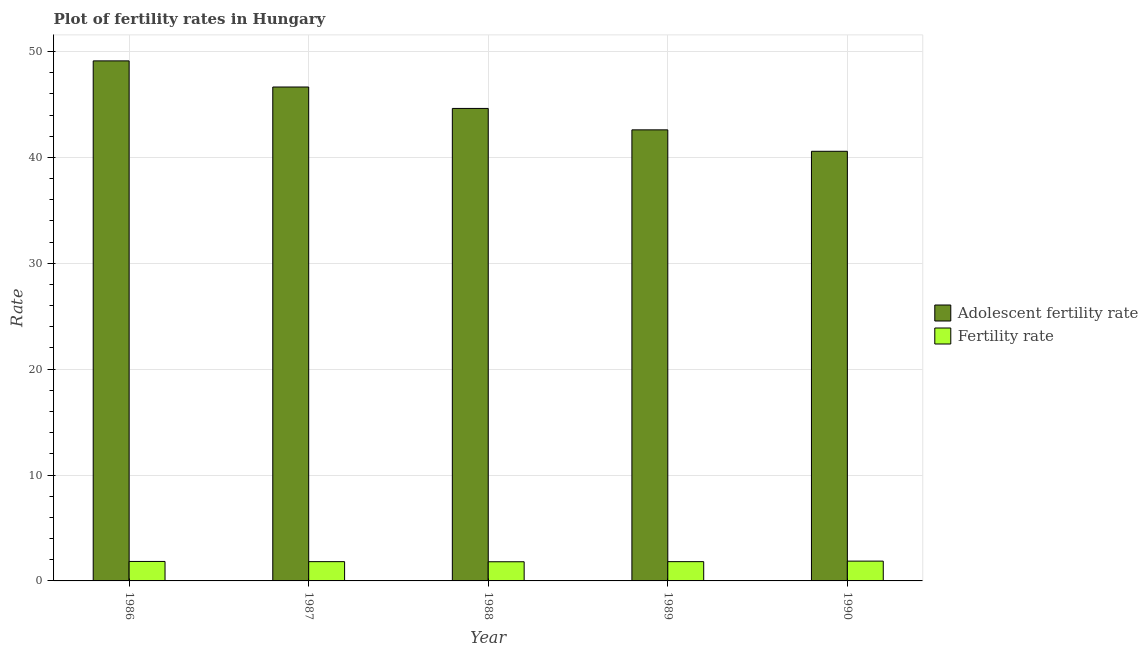How many groups of bars are there?
Provide a short and direct response. 5. Are the number of bars per tick equal to the number of legend labels?
Provide a short and direct response. Yes. How many bars are there on the 1st tick from the left?
Ensure brevity in your answer.  2. What is the adolescent fertility rate in 1987?
Make the answer very short. 46.65. Across all years, what is the maximum adolescent fertility rate?
Your answer should be compact. 49.12. Across all years, what is the minimum adolescent fertility rate?
Your response must be concise. 40.58. What is the total fertility rate in the graph?
Provide a short and direct response. 9.16. What is the difference between the fertility rate in 1987 and that in 1988?
Your response must be concise. 0.01. What is the difference between the fertility rate in 1988 and the adolescent fertility rate in 1989?
Provide a succinct answer. -0.01. What is the average adolescent fertility rate per year?
Offer a terse response. 44.71. What is the ratio of the fertility rate in 1989 to that in 1990?
Offer a terse response. 0.97. Is the fertility rate in 1986 less than that in 1990?
Make the answer very short. Yes. What is the difference between the highest and the second highest adolescent fertility rate?
Give a very brief answer. 2.47. What is the difference between the highest and the lowest adolescent fertility rate?
Provide a succinct answer. 8.54. In how many years, is the adolescent fertility rate greater than the average adolescent fertility rate taken over all years?
Give a very brief answer. 2. What does the 1st bar from the left in 1987 represents?
Offer a terse response. Adolescent fertility rate. What does the 2nd bar from the right in 1989 represents?
Your answer should be very brief. Adolescent fertility rate. What is the difference between two consecutive major ticks on the Y-axis?
Ensure brevity in your answer.  10. Does the graph contain grids?
Provide a succinct answer. Yes. Where does the legend appear in the graph?
Your answer should be very brief. Center right. How are the legend labels stacked?
Give a very brief answer. Vertical. What is the title of the graph?
Provide a short and direct response. Plot of fertility rates in Hungary. Does "Fixed telephone" appear as one of the legend labels in the graph?
Your response must be concise. No. What is the label or title of the X-axis?
Your answer should be very brief. Year. What is the label or title of the Y-axis?
Provide a short and direct response. Rate. What is the Rate in Adolescent fertility rate in 1986?
Provide a short and direct response. 49.12. What is the Rate in Fertility rate in 1986?
Your answer should be very brief. 1.84. What is the Rate of Adolescent fertility rate in 1987?
Keep it short and to the point. 46.65. What is the Rate of Fertility rate in 1987?
Give a very brief answer. 1.82. What is the Rate of Adolescent fertility rate in 1988?
Your answer should be compact. 44.63. What is the Rate of Fertility rate in 1988?
Offer a very short reply. 1.81. What is the Rate of Adolescent fertility rate in 1989?
Offer a terse response. 42.6. What is the Rate of Fertility rate in 1989?
Make the answer very short. 1.82. What is the Rate in Adolescent fertility rate in 1990?
Provide a short and direct response. 40.58. What is the Rate of Fertility rate in 1990?
Provide a short and direct response. 1.87. Across all years, what is the maximum Rate of Adolescent fertility rate?
Give a very brief answer. 49.12. Across all years, what is the maximum Rate of Fertility rate?
Keep it short and to the point. 1.87. Across all years, what is the minimum Rate of Adolescent fertility rate?
Provide a succinct answer. 40.58. Across all years, what is the minimum Rate in Fertility rate?
Give a very brief answer. 1.81. What is the total Rate in Adolescent fertility rate in the graph?
Your answer should be compact. 223.57. What is the total Rate of Fertility rate in the graph?
Your answer should be compact. 9.16. What is the difference between the Rate of Adolescent fertility rate in 1986 and that in 1987?
Your response must be concise. 2.47. What is the difference between the Rate of Fertility rate in 1986 and that in 1987?
Ensure brevity in your answer.  0.02. What is the difference between the Rate of Adolescent fertility rate in 1986 and that in 1988?
Your response must be concise. 4.49. What is the difference between the Rate of Adolescent fertility rate in 1986 and that in 1989?
Your response must be concise. 6.51. What is the difference between the Rate in Fertility rate in 1986 and that in 1989?
Give a very brief answer. 0.02. What is the difference between the Rate of Adolescent fertility rate in 1986 and that in 1990?
Your answer should be compact. 8.54. What is the difference between the Rate in Fertility rate in 1986 and that in 1990?
Give a very brief answer. -0.03. What is the difference between the Rate in Adolescent fertility rate in 1987 and that in 1988?
Offer a terse response. 2.02. What is the difference between the Rate in Fertility rate in 1987 and that in 1988?
Provide a short and direct response. 0.01. What is the difference between the Rate in Adolescent fertility rate in 1987 and that in 1989?
Your response must be concise. 4.05. What is the difference between the Rate of Fertility rate in 1987 and that in 1989?
Your response must be concise. 0. What is the difference between the Rate of Adolescent fertility rate in 1987 and that in 1990?
Your response must be concise. 6.07. What is the difference between the Rate in Fertility rate in 1987 and that in 1990?
Your response must be concise. -0.05. What is the difference between the Rate of Adolescent fertility rate in 1988 and that in 1989?
Keep it short and to the point. 2.02. What is the difference between the Rate of Fertility rate in 1988 and that in 1989?
Make the answer very short. -0.01. What is the difference between the Rate of Adolescent fertility rate in 1988 and that in 1990?
Your response must be concise. 4.05. What is the difference between the Rate of Fertility rate in 1988 and that in 1990?
Offer a very short reply. -0.06. What is the difference between the Rate in Adolescent fertility rate in 1989 and that in 1990?
Your response must be concise. 2.02. What is the difference between the Rate of Fertility rate in 1989 and that in 1990?
Make the answer very short. -0.05. What is the difference between the Rate of Adolescent fertility rate in 1986 and the Rate of Fertility rate in 1987?
Make the answer very short. 47.3. What is the difference between the Rate in Adolescent fertility rate in 1986 and the Rate in Fertility rate in 1988?
Provide a short and direct response. 47.31. What is the difference between the Rate of Adolescent fertility rate in 1986 and the Rate of Fertility rate in 1989?
Provide a short and direct response. 47.3. What is the difference between the Rate of Adolescent fertility rate in 1986 and the Rate of Fertility rate in 1990?
Ensure brevity in your answer.  47.25. What is the difference between the Rate of Adolescent fertility rate in 1987 and the Rate of Fertility rate in 1988?
Ensure brevity in your answer.  44.84. What is the difference between the Rate of Adolescent fertility rate in 1987 and the Rate of Fertility rate in 1989?
Keep it short and to the point. 44.83. What is the difference between the Rate in Adolescent fertility rate in 1987 and the Rate in Fertility rate in 1990?
Your answer should be compact. 44.78. What is the difference between the Rate in Adolescent fertility rate in 1988 and the Rate in Fertility rate in 1989?
Your answer should be compact. 42.81. What is the difference between the Rate of Adolescent fertility rate in 1988 and the Rate of Fertility rate in 1990?
Provide a succinct answer. 42.76. What is the difference between the Rate in Adolescent fertility rate in 1989 and the Rate in Fertility rate in 1990?
Your response must be concise. 40.73. What is the average Rate in Adolescent fertility rate per year?
Provide a succinct answer. 44.71. What is the average Rate in Fertility rate per year?
Keep it short and to the point. 1.83. In the year 1986, what is the difference between the Rate of Adolescent fertility rate and Rate of Fertility rate?
Make the answer very short. 47.28. In the year 1987, what is the difference between the Rate in Adolescent fertility rate and Rate in Fertility rate?
Ensure brevity in your answer.  44.83. In the year 1988, what is the difference between the Rate of Adolescent fertility rate and Rate of Fertility rate?
Your answer should be compact. 42.82. In the year 1989, what is the difference between the Rate of Adolescent fertility rate and Rate of Fertility rate?
Ensure brevity in your answer.  40.78. In the year 1990, what is the difference between the Rate of Adolescent fertility rate and Rate of Fertility rate?
Your answer should be very brief. 38.71. What is the ratio of the Rate of Adolescent fertility rate in 1986 to that in 1987?
Give a very brief answer. 1.05. What is the ratio of the Rate in Fertility rate in 1986 to that in 1987?
Give a very brief answer. 1.01. What is the ratio of the Rate in Adolescent fertility rate in 1986 to that in 1988?
Your answer should be very brief. 1.1. What is the ratio of the Rate in Fertility rate in 1986 to that in 1988?
Offer a very short reply. 1.02. What is the ratio of the Rate in Adolescent fertility rate in 1986 to that in 1989?
Your answer should be very brief. 1.15. What is the ratio of the Rate in Adolescent fertility rate in 1986 to that in 1990?
Give a very brief answer. 1.21. What is the ratio of the Rate of Adolescent fertility rate in 1987 to that in 1988?
Provide a succinct answer. 1.05. What is the ratio of the Rate of Adolescent fertility rate in 1987 to that in 1989?
Provide a short and direct response. 1.09. What is the ratio of the Rate of Fertility rate in 1987 to that in 1989?
Your response must be concise. 1. What is the ratio of the Rate of Adolescent fertility rate in 1987 to that in 1990?
Provide a succinct answer. 1.15. What is the ratio of the Rate in Fertility rate in 1987 to that in 1990?
Provide a succinct answer. 0.97. What is the ratio of the Rate of Adolescent fertility rate in 1988 to that in 1989?
Provide a short and direct response. 1.05. What is the ratio of the Rate in Fertility rate in 1988 to that in 1989?
Offer a very short reply. 0.99. What is the ratio of the Rate of Adolescent fertility rate in 1988 to that in 1990?
Your answer should be compact. 1.1. What is the ratio of the Rate in Fertility rate in 1988 to that in 1990?
Offer a very short reply. 0.97. What is the ratio of the Rate in Adolescent fertility rate in 1989 to that in 1990?
Your answer should be very brief. 1.05. What is the ratio of the Rate in Fertility rate in 1989 to that in 1990?
Make the answer very short. 0.97. What is the difference between the highest and the second highest Rate in Adolescent fertility rate?
Keep it short and to the point. 2.47. What is the difference between the highest and the second highest Rate in Fertility rate?
Provide a succinct answer. 0.03. What is the difference between the highest and the lowest Rate of Adolescent fertility rate?
Offer a very short reply. 8.54. What is the difference between the highest and the lowest Rate of Fertility rate?
Offer a terse response. 0.06. 